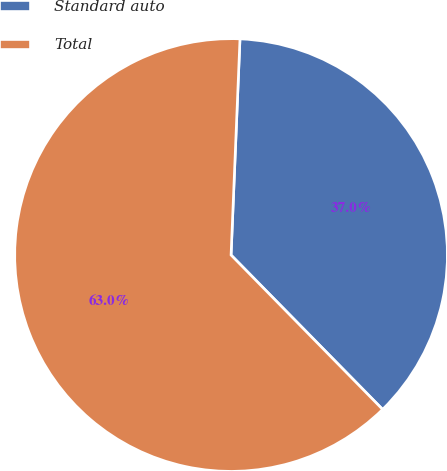Convert chart to OTSL. <chart><loc_0><loc_0><loc_500><loc_500><pie_chart><fcel>Standard auto<fcel>Total<nl><fcel>36.99%<fcel>63.01%<nl></chart> 